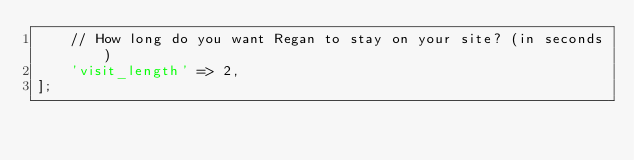Convert code to text. <code><loc_0><loc_0><loc_500><loc_500><_PHP_>    // How long do you want Regan to stay on your site? (in seconds)
    'visit_length' => 2,
];
</code> 